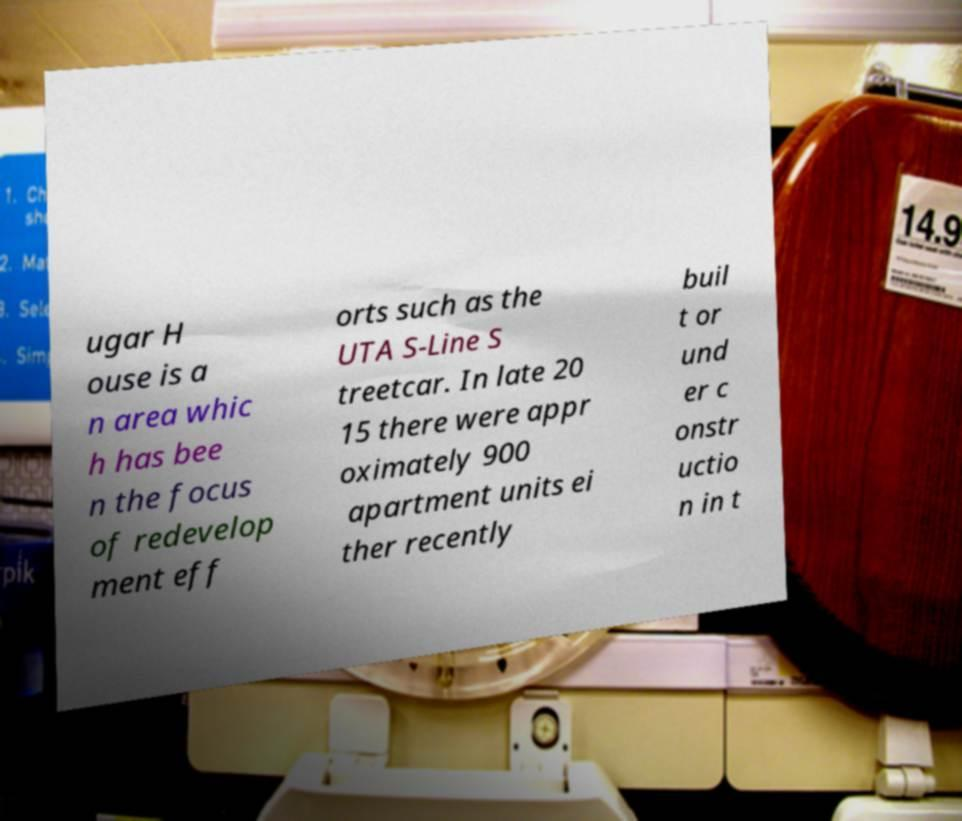Could you extract and type out the text from this image? ugar H ouse is a n area whic h has bee n the focus of redevelop ment eff orts such as the UTA S-Line S treetcar. In late 20 15 there were appr oximately 900 apartment units ei ther recently buil t or und er c onstr uctio n in t 